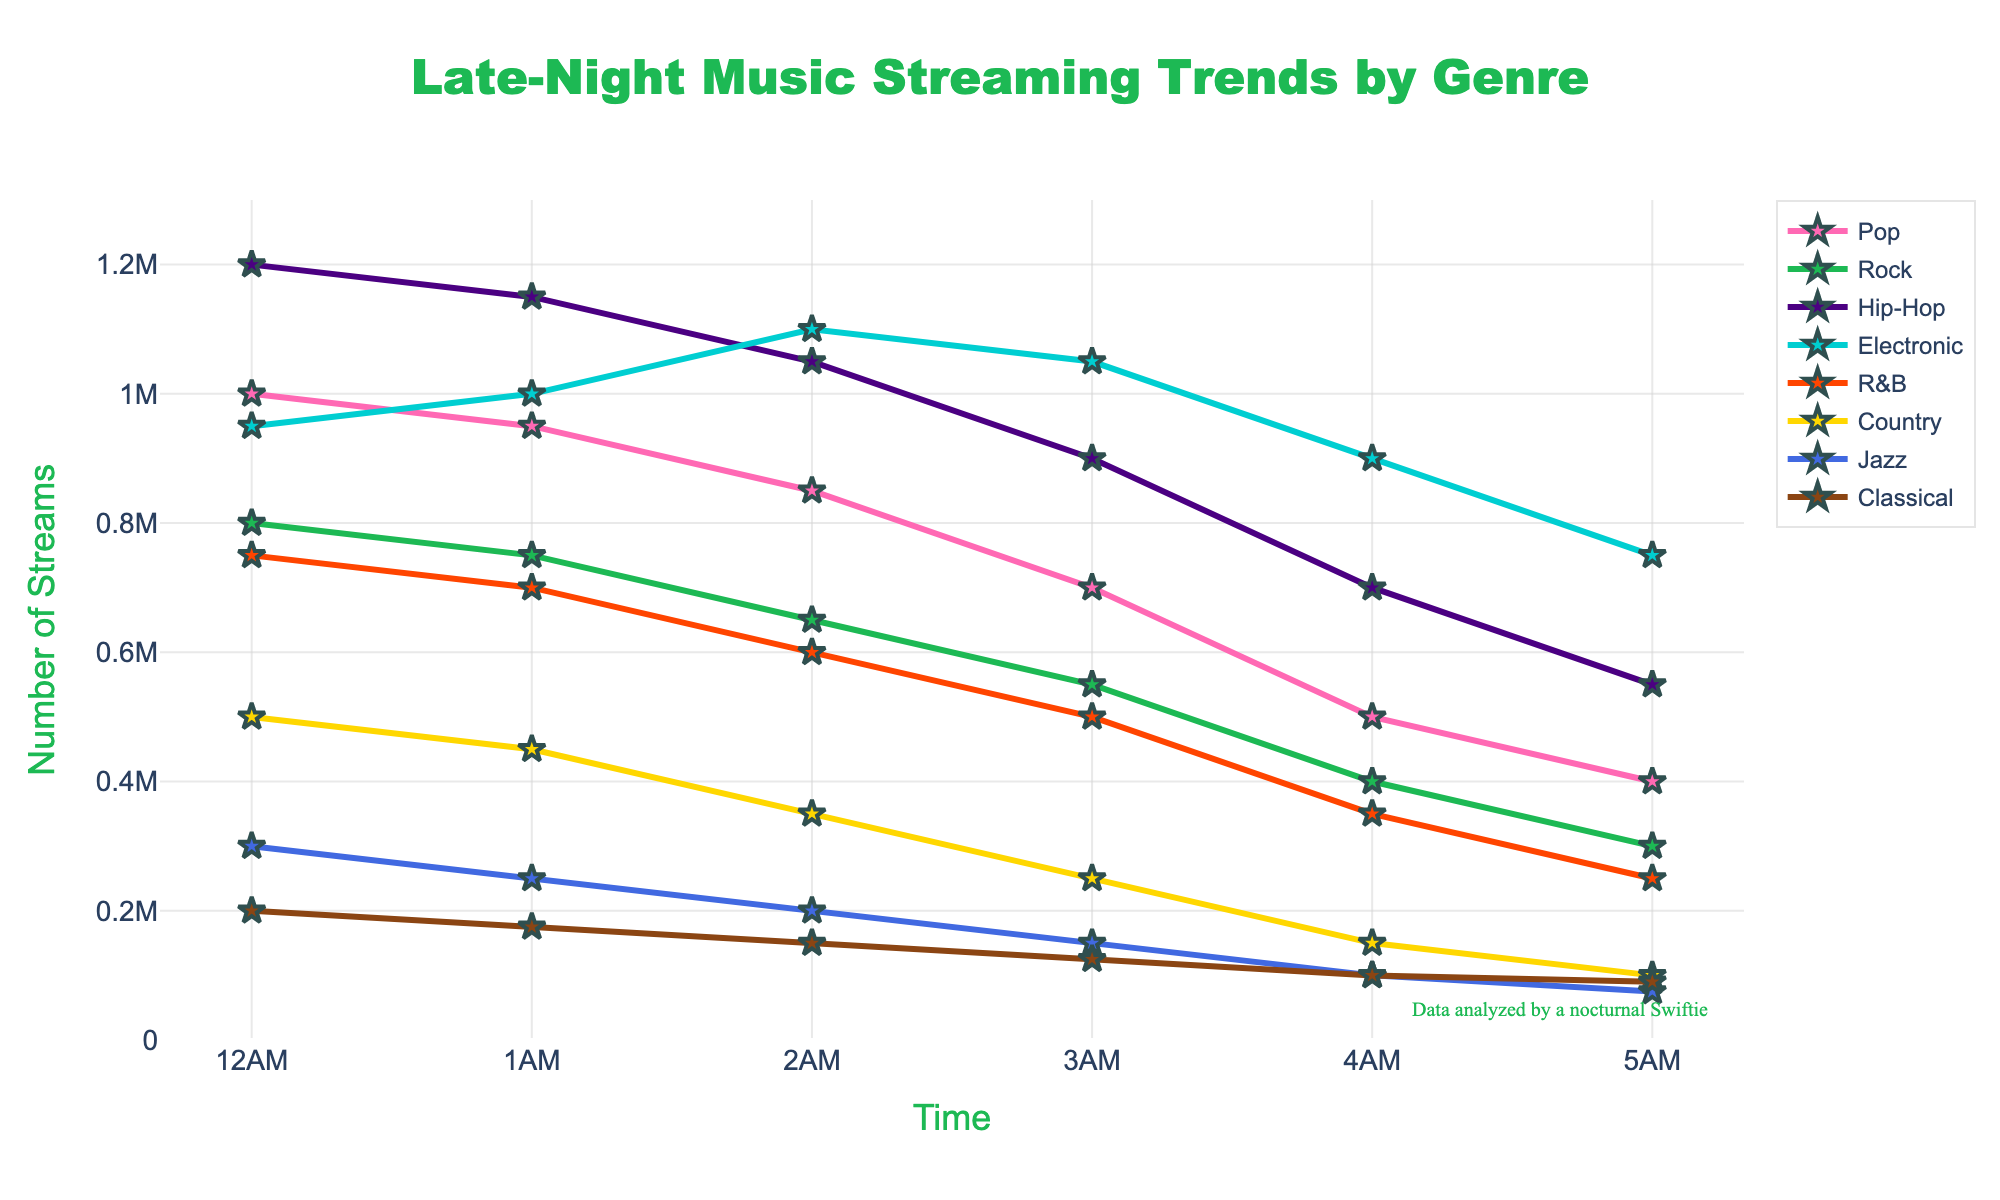What genre has the highest streaming numbers at 2 AM? Looking at the chart, the Hip-Hop line is the highest at 2 AM, indicating it has the highest streaming numbers.
Answer: Hip-Hop Which genre shows an increasing trend in streams from 12 AM to 2 AM? By examining the lines, the Electronic genre shows an upward trend between 12 AM and 2 AM.
Answer: Electronic How does the streaming number of R&B at 3 AM compare to that of Pop at the same time? At 3 AM, the streaming number for R&B is 500,000, while for Pop it is 700,000. So, Pop has higher streaming numbers.
Answer: Pop has higher What is the total number of streams for Rock from 12 AM to 5 AM? Sum the streams for Rock at each hour: 800,000 + 750,000 + 650,000 + 550,000 + 400,000 + 300,000 = 3,450,000.
Answer: 3,450,000 Which two genres have the closest number of streams at 1 AM? At 1 AM, the closest numbers are Pop (950,000) and Electronic (1,000,000), a difference of 50,000.
Answer: Pop and Electronic What is the difference in streams between Hip-Hop and Classical at 5 AM? At 5 AM, the streams for Hip-Hop are 550,000, and for Classical, it is 90,000. The difference is 550,000 - 90,000 = 460,000.
Answer: 460,000 Does the jazz genre ever surpass the Country genre in streams during the given time frame? By comparing the lines, Jazz never surpasses Country in any of the hours.
Answer: No Which genre starts with the highest number of streams at midnight (12 AM)? The Hip-Hop genre starts with the highest number of streams at 12 AM.
Answer: Hip-Hop What is the average number of streams for Pop across all the given time points? Sum the streams for Pop (1,000,000 + 950,000 + 850,000 + 700,000 + 500,000 + 400,000 = 4,400,000) and divide by 6 (4,400,000 / 6 ≈ 733,333).
Answer: 733,333 What is the trend of streams for Classical music from 12 AM to 5 AM? The line shows a consistent decrease in the number of streams from 200,000 at 12 AM to 90,000 at 5 AM.
Answer: Decreasing 